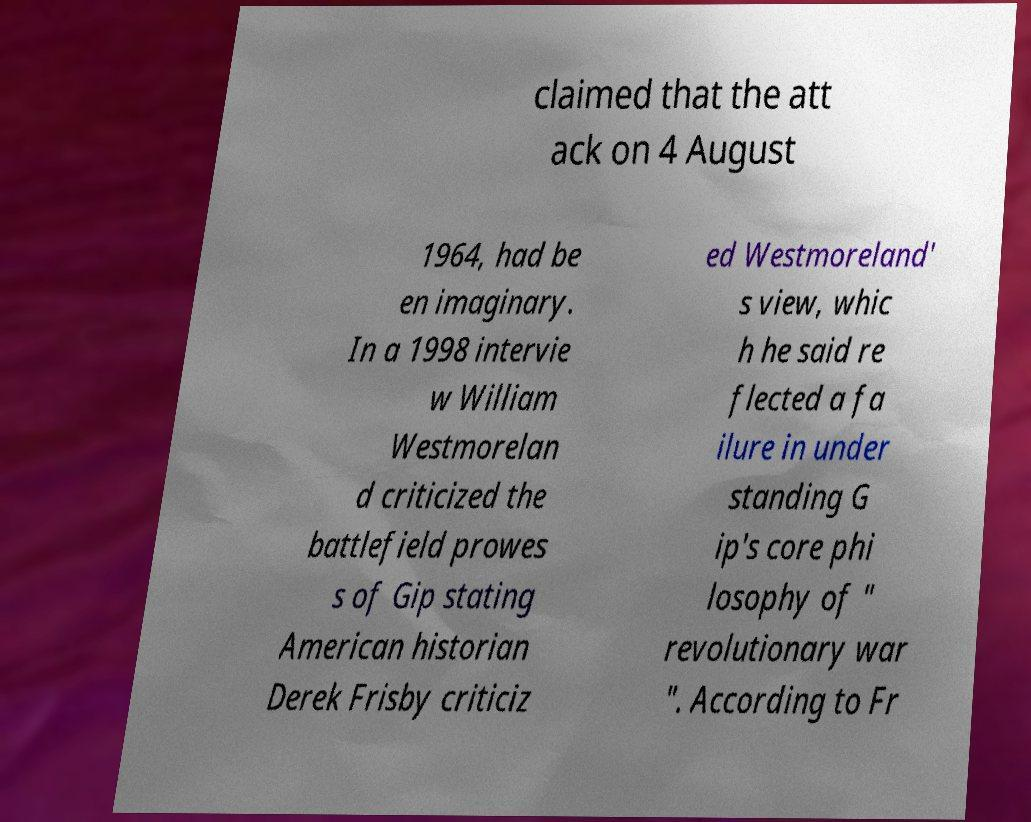Can you read and provide the text displayed in the image?This photo seems to have some interesting text. Can you extract and type it out for me? claimed that the att ack on 4 August 1964, had be en imaginary. In a 1998 intervie w William Westmorelan d criticized the battlefield prowes s of Gip stating American historian Derek Frisby criticiz ed Westmoreland' s view, whic h he said re flected a fa ilure in under standing G ip's core phi losophy of " revolutionary war ". According to Fr 